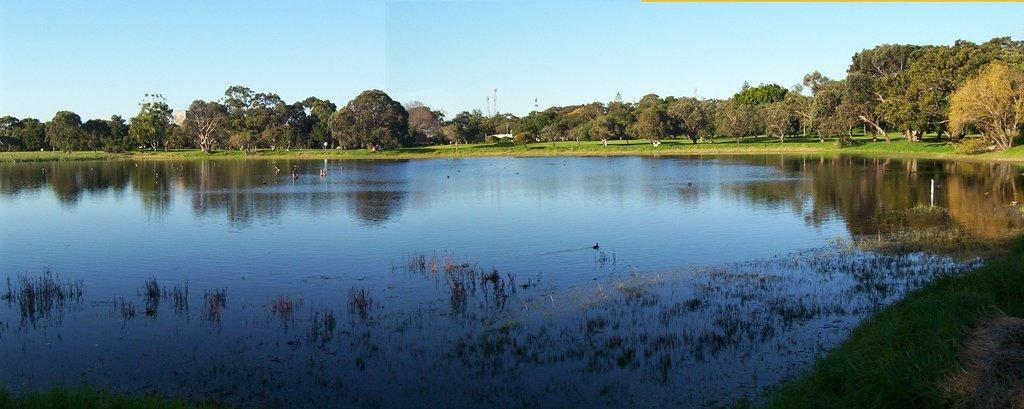What is the primary element visible in the image? There is water in the image. What type of vegetation can be seen in the image? There are many trees in the image. What is visible at the top of the image? The sky is clear and visible at the top of the image. Where is the dog sitting in the image? There is no dog present in the image. What type of branch can be seen on the shelf in the image? There is no shelf or branch present in the image. 